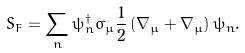<formula> <loc_0><loc_0><loc_500><loc_500>S _ { F } = \sum _ { n } \psi _ { n } ^ { \dagger } \sigma _ { \mu } \frac { 1 } { 2 } \left ( \nabla _ { \mu } + \bar { \nabla } _ { \mu } \right ) \psi _ { n } .</formula> 